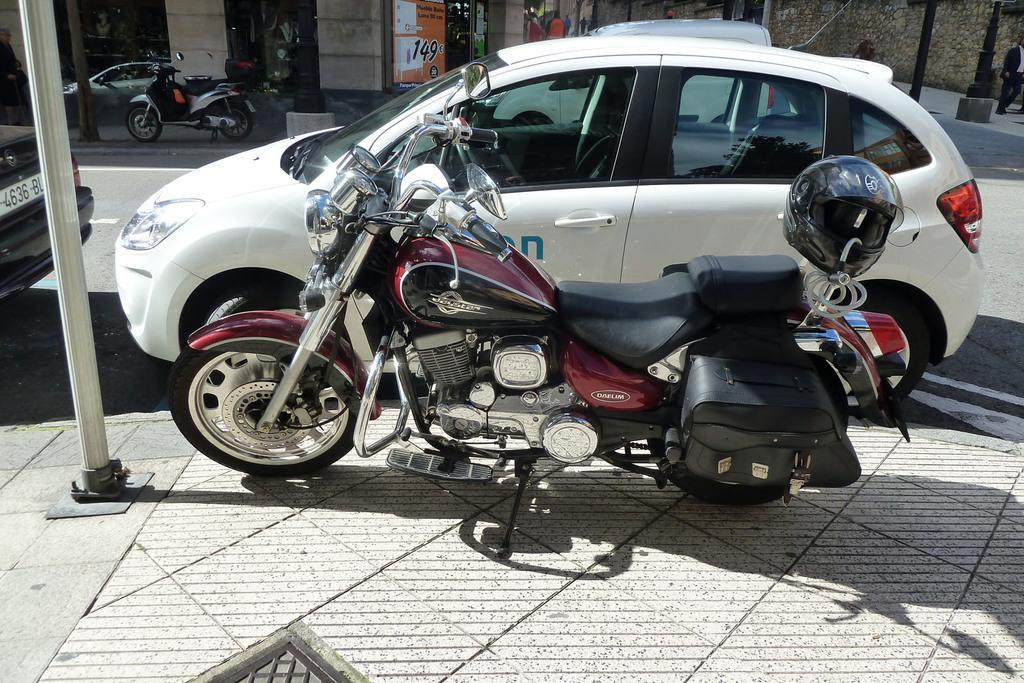What type of vehicles can be seen in the image? There are motorcycles and cars in the image. What else is present in the image besides vehicles? There is a banner in the image. What can be seen in the background of the image? There are buildings and plants in the background of the image. What type of ear is visible on the motorcycle in the image? There are no ears visible in the image, as motorcycles do not have ears. 